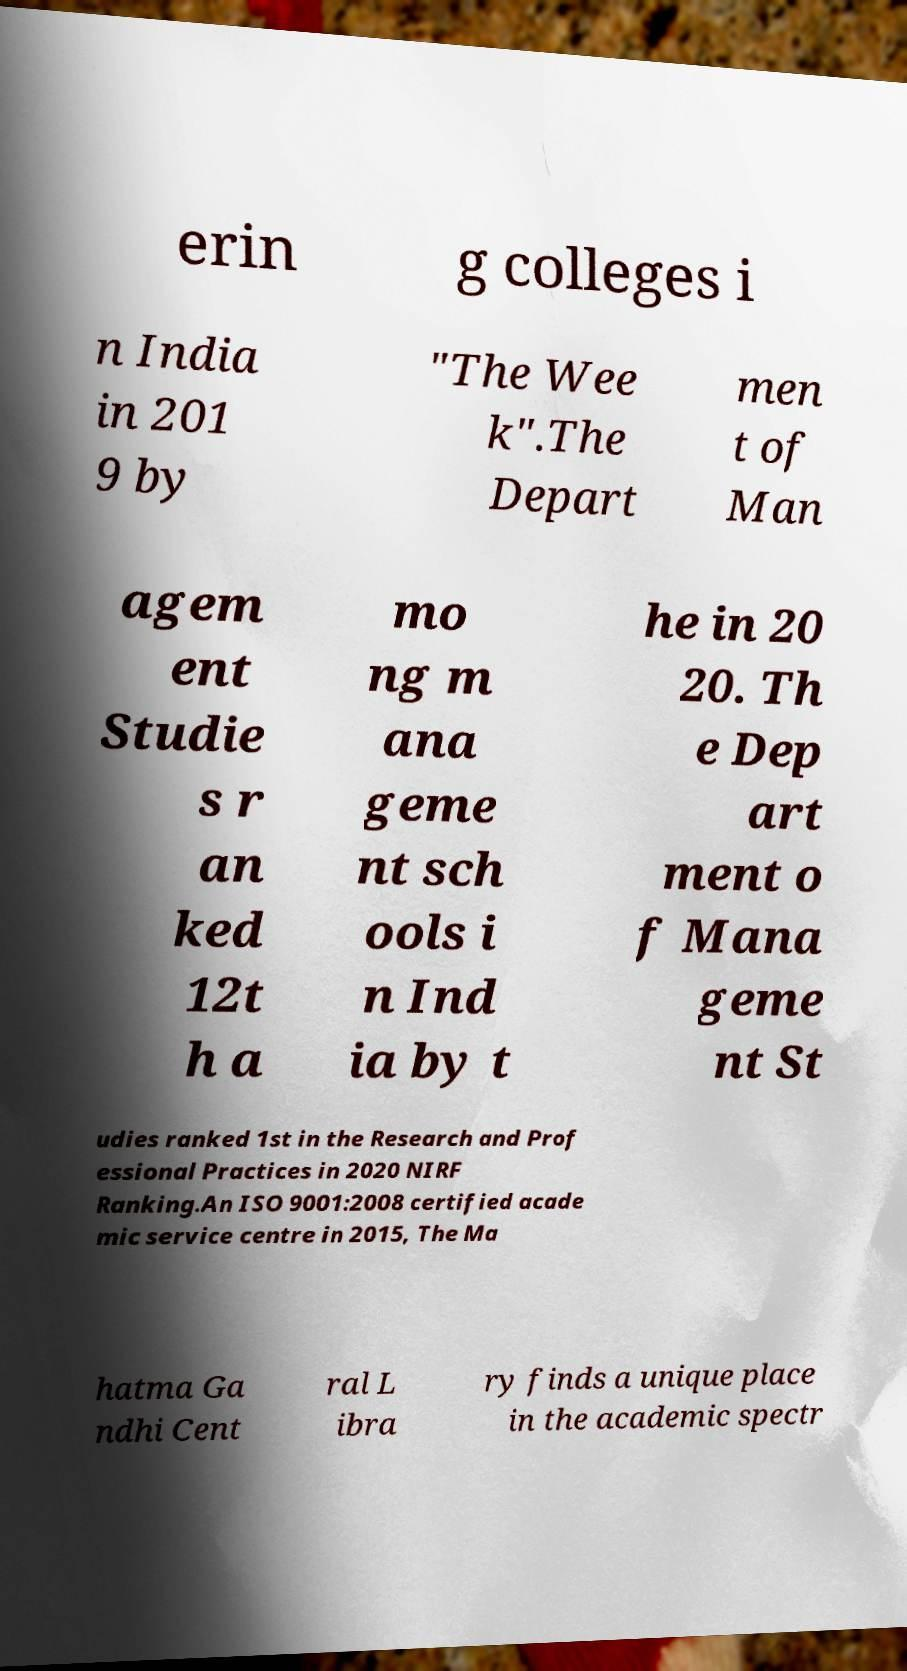For documentation purposes, I need the text within this image transcribed. Could you provide that? erin g colleges i n India in 201 9 by "The Wee k".The Depart men t of Man agem ent Studie s r an ked 12t h a mo ng m ana geme nt sch ools i n Ind ia by t he in 20 20. Th e Dep art ment o f Mana geme nt St udies ranked 1st in the Research and Prof essional Practices in 2020 NIRF Ranking.An ISO 9001:2008 certified acade mic service centre in 2015, The Ma hatma Ga ndhi Cent ral L ibra ry finds a unique place in the academic spectr 